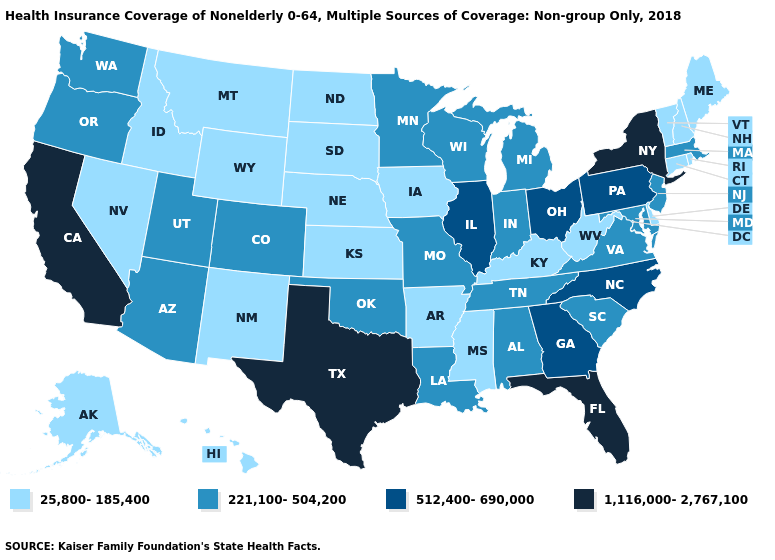What is the value of North Dakota?
Concise answer only. 25,800-185,400. What is the highest value in states that border Wisconsin?
Short answer required. 512,400-690,000. Name the states that have a value in the range 25,800-185,400?
Be succinct. Alaska, Arkansas, Connecticut, Delaware, Hawaii, Idaho, Iowa, Kansas, Kentucky, Maine, Mississippi, Montana, Nebraska, Nevada, New Hampshire, New Mexico, North Dakota, Rhode Island, South Dakota, Vermont, West Virginia, Wyoming. What is the value of Maryland?
Be succinct. 221,100-504,200. What is the value of New Jersey?
Be succinct. 221,100-504,200. Among the states that border Massachusetts , does New York have the highest value?
Answer briefly. Yes. Name the states that have a value in the range 25,800-185,400?
Short answer required. Alaska, Arkansas, Connecticut, Delaware, Hawaii, Idaho, Iowa, Kansas, Kentucky, Maine, Mississippi, Montana, Nebraska, Nevada, New Hampshire, New Mexico, North Dakota, Rhode Island, South Dakota, Vermont, West Virginia, Wyoming. What is the lowest value in the MidWest?
Give a very brief answer. 25,800-185,400. Name the states that have a value in the range 1,116,000-2,767,100?
Be succinct. California, Florida, New York, Texas. Among the states that border Wisconsin , does Minnesota have the lowest value?
Keep it brief. No. Name the states that have a value in the range 221,100-504,200?
Short answer required. Alabama, Arizona, Colorado, Indiana, Louisiana, Maryland, Massachusetts, Michigan, Minnesota, Missouri, New Jersey, Oklahoma, Oregon, South Carolina, Tennessee, Utah, Virginia, Washington, Wisconsin. Name the states that have a value in the range 25,800-185,400?
Write a very short answer. Alaska, Arkansas, Connecticut, Delaware, Hawaii, Idaho, Iowa, Kansas, Kentucky, Maine, Mississippi, Montana, Nebraska, Nevada, New Hampshire, New Mexico, North Dakota, Rhode Island, South Dakota, Vermont, West Virginia, Wyoming. Which states have the lowest value in the USA?
Write a very short answer. Alaska, Arkansas, Connecticut, Delaware, Hawaii, Idaho, Iowa, Kansas, Kentucky, Maine, Mississippi, Montana, Nebraska, Nevada, New Hampshire, New Mexico, North Dakota, Rhode Island, South Dakota, Vermont, West Virginia, Wyoming. What is the highest value in the USA?
Write a very short answer. 1,116,000-2,767,100. What is the value of Wisconsin?
Answer briefly. 221,100-504,200. 